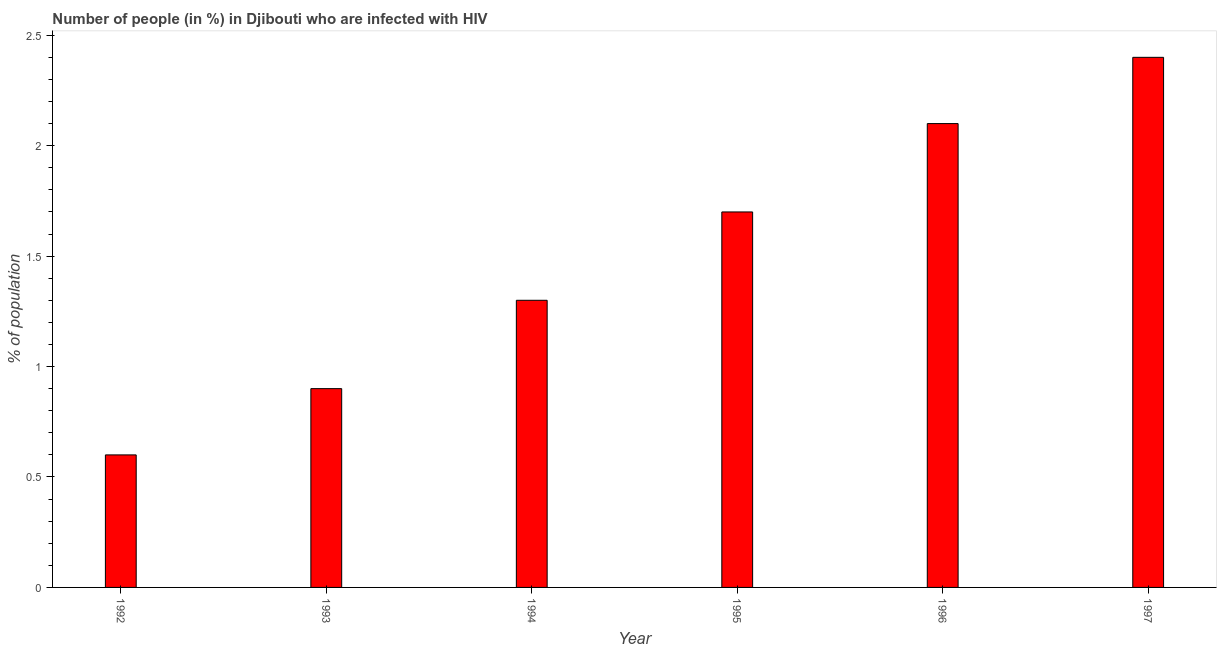Does the graph contain grids?
Ensure brevity in your answer.  No. What is the title of the graph?
Make the answer very short. Number of people (in %) in Djibouti who are infected with HIV. What is the label or title of the X-axis?
Your answer should be compact. Year. What is the label or title of the Y-axis?
Provide a short and direct response. % of population. Across all years, what is the maximum number of people infected with hiv?
Provide a succinct answer. 2.4. In which year was the number of people infected with hiv minimum?
Offer a terse response. 1992. What is the average number of people infected with hiv per year?
Your response must be concise. 1.5. What is the median number of people infected with hiv?
Your answer should be compact. 1.5. In how many years, is the number of people infected with hiv greater than 2.4 %?
Your answer should be compact. 0. Do a majority of the years between 1995 and 1994 (inclusive) have number of people infected with hiv greater than 0.1 %?
Provide a succinct answer. No. Is the sum of the number of people infected with hiv in 1993 and 1997 greater than the maximum number of people infected with hiv across all years?
Make the answer very short. Yes. How many bars are there?
Provide a short and direct response. 6. How many years are there in the graph?
Your response must be concise. 6. Are the values on the major ticks of Y-axis written in scientific E-notation?
Your answer should be compact. No. What is the % of population of 1992?
Your answer should be very brief. 0.6. What is the % of population in 1994?
Ensure brevity in your answer.  1.3. What is the % of population of 1995?
Give a very brief answer. 1.7. What is the difference between the % of population in 1992 and 1994?
Your answer should be very brief. -0.7. What is the difference between the % of population in 1992 and 1995?
Provide a succinct answer. -1.1. What is the difference between the % of population in 1992 and 1996?
Ensure brevity in your answer.  -1.5. What is the difference between the % of population in 1993 and 1996?
Give a very brief answer. -1.2. What is the difference between the % of population in 1993 and 1997?
Your answer should be very brief. -1.5. What is the difference between the % of population in 1994 and 1996?
Your answer should be compact. -0.8. What is the difference between the % of population in 1994 and 1997?
Offer a terse response. -1.1. What is the difference between the % of population in 1995 and 1996?
Offer a very short reply. -0.4. What is the difference between the % of population in 1995 and 1997?
Make the answer very short. -0.7. What is the ratio of the % of population in 1992 to that in 1993?
Offer a very short reply. 0.67. What is the ratio of the % of population in 1992 to that in 1994?
Keep it short and to the point. 0.46. What is the ratio of the % of population in 1992 to that in 1995?
Your response must be concise. 0.35. What is the ratio of the % of population in 1992 to that in 1996?
Offer a terse response. 0.29. What is the ratio of the % of population in 1992 to that in 1997?
Your response must be concise. 0.25. What is the ratio of the % of population in 1993 to that in 1994?
Your answer should be very brief. 0.69. What is the ratio of the % of population in 1993 to that in 1995?
Make the answer very short. 0.53. What is the ratio of the % of population in 1993 to that in 1996?
Make the answer very short. 0.43. What is the ratio of the % of population in 1993 to that in 1997?
Provide a succinct answer. 0.38. What is the ratio of the % of population in 1994 to that in 1995?
Make the answer very short. 0.77. What is the ratio of the % of population in 1994 to that in 1996?
Ensure brevity in your answer.  0.62. What is the ratio of the % of population in 1994 to that in 1997?
Your answer should be very brief. 0.54. What is the ratio of the % of population in 1995 to that in 1996?
Your answer should be very brief. 0.81. What is the ratio of the % of population in 1995 to that in 1997?
Provide a short and direct response. 0.71. What is the ratio of the % of population in 1996 to that in 1997?
Offer a terse response. 0.88. 